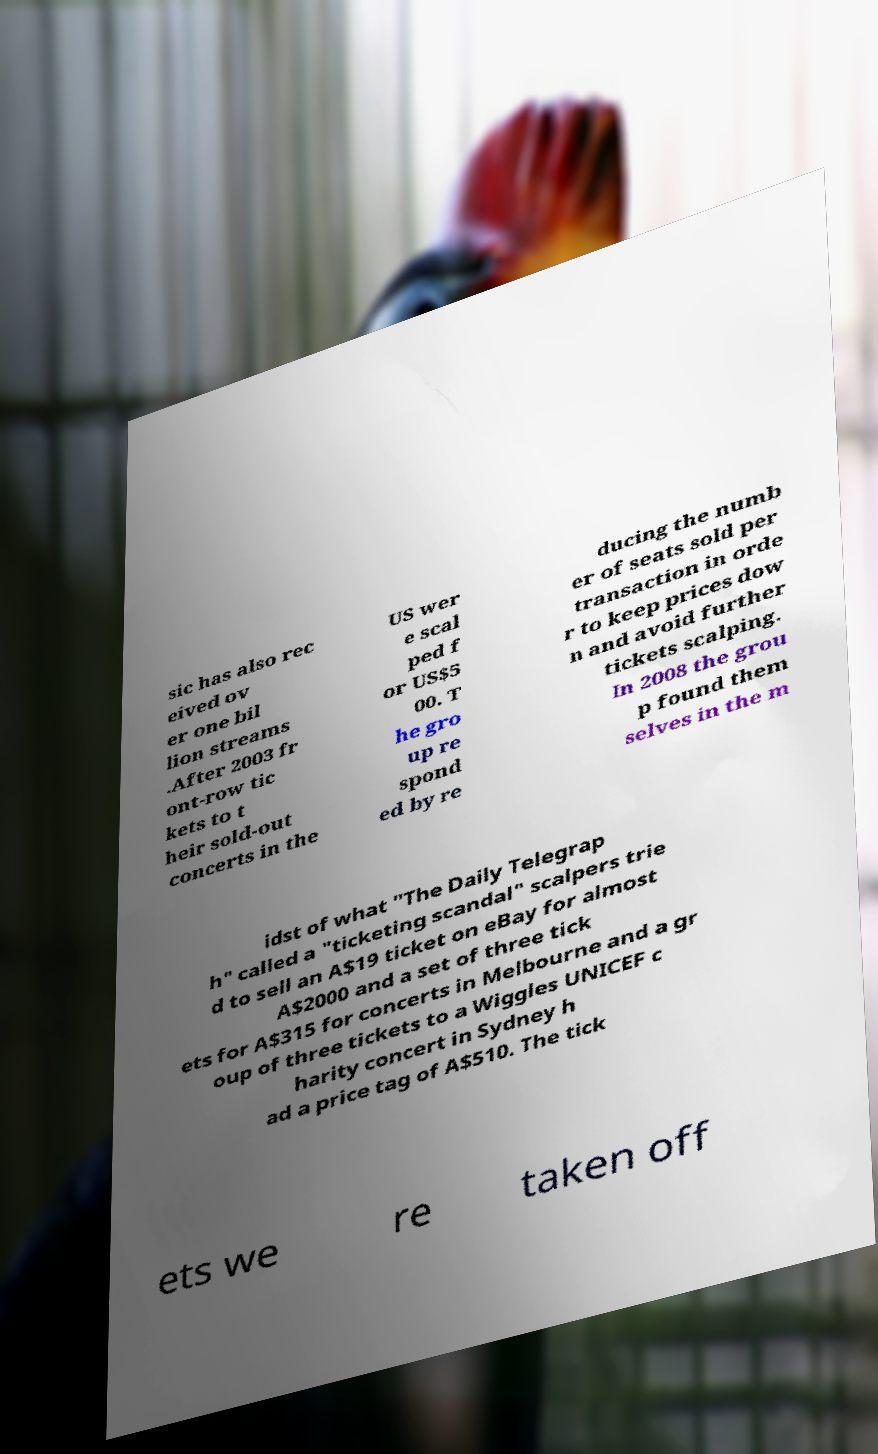Can you read and provide the text displayed in the image?This photo seems to have some interesting text. Can you extract and type it out for me? sic has also rec eived ov er one bil lion streams .After 2003 fr ont-row tic kets to t heir sold-out concerts in the US wer e scal ped f or US$5 00. T he gro up re spond ed by re ducing the numb er of seats sold per transaction in orde r to keep prices dow n and avoid further tickets scalping. In 2008 the grou p found them selves in the m idst of what "The Daily Telegrap h" called a "ticketing scandal" scalpers trie d to sell an A$19 ticket on eBay for almost A$2000 and a set of three tick ets for A$315 for concerts in Melbourne and a gr oup of three tickets to a Wiggles UNICEF c harity concert in Sydney h ad a price tag of A$510. The tick ets we re taken off 